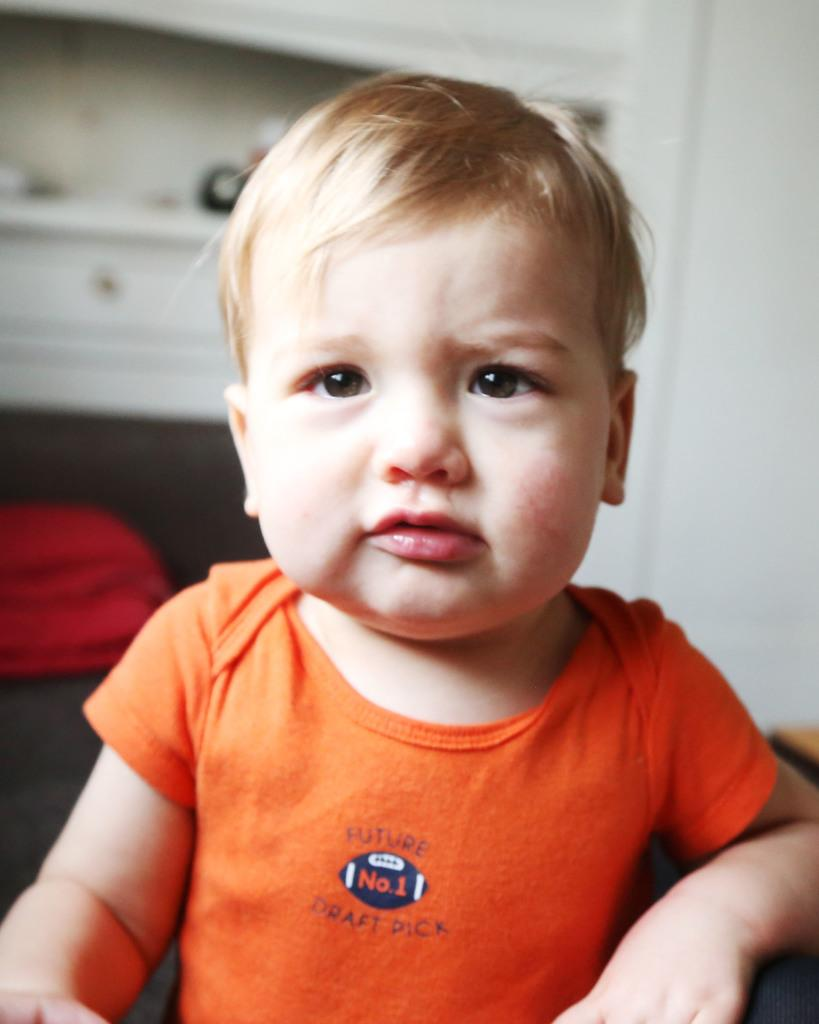What is the main subject of the image? The main subject of the image is a kid. Can you describe any objects visible in the background of the image? The objects in the background may be blurry, but they are still visible. How many matches can be seen in the image? There are no matches present in the image. What is the kid pointing at in the image? The provided facts do not mention the kid pointing at anything, so we cannot answer this question definitively. 